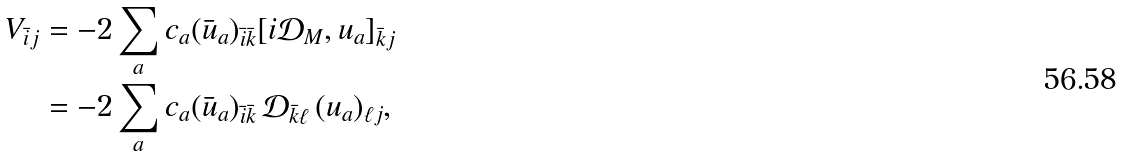Convert formula to latex. <formula><loc_0><loc_0><loc_500><loc_500>V _ { \bar { i } j } & = - 2 \sum _ { a } c _ { a } ( \bar { u } _ { a } ) _ { \bar { i } \bar { k } } [ i \mathcal { D } _ { M } , u _ { a } ] _ { \bar { k } j } \\ & = - 2 \sum _ { a } c _ { a } ( \bar { u } _ { a } ) _ { \bar { i } \bar { k } } \, \mathcal { D } _ { \bar { k } \ell } \, ( u _ { a } ) _ { \ell j } ,</formula> 